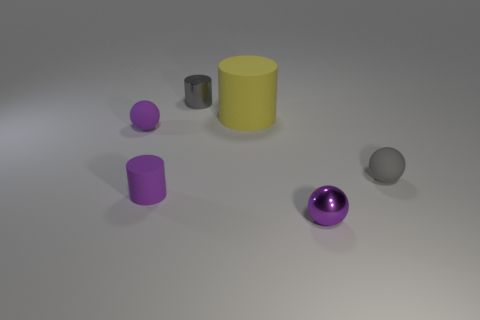Are there any other things that are the same size as the yellow rubber thing?
Ensure brevity in your answer.  No. There is a gray metallic object that is behind the small sphere that is behind the gray ball; how many cylinders are in front of it?
Offer a terse response. 2. Does the small object on the right side of the shiny ball have the same shape as the purple metal object?
Your answer should be compact. Yes. What number of things are either tiny purple matte things or tiny purple balls behind the purple cylinder?
Provide a succinct answer. 2. Is the number of purple matte balls that are left of the big yellow rubber object greater than the number of large shiny blocks?
Provide a succinct answer. Yes. Is the number of purple matte balls that are right of the gray metal cylinder the same as the number of small purple cylinders that are left of the tiny matte cylinder?
Offer a very short reply. Yes. Is there a tiny purple sphere that is in front of the tiny purple ball that is behind the purple metal object?
Your answer should be very brief. Yes. What is the shape of the large rubber thing?
Your response must be concise. Cylinder. There is a matte cylinder behind the cylinder in front of the tiny gray sphere; what size is it?
Give a very brief answer. Large. What is the size of the rubber cylinder that is on the right side of the shiny cylinder?
Ensure brevity in your answer.  Large. 